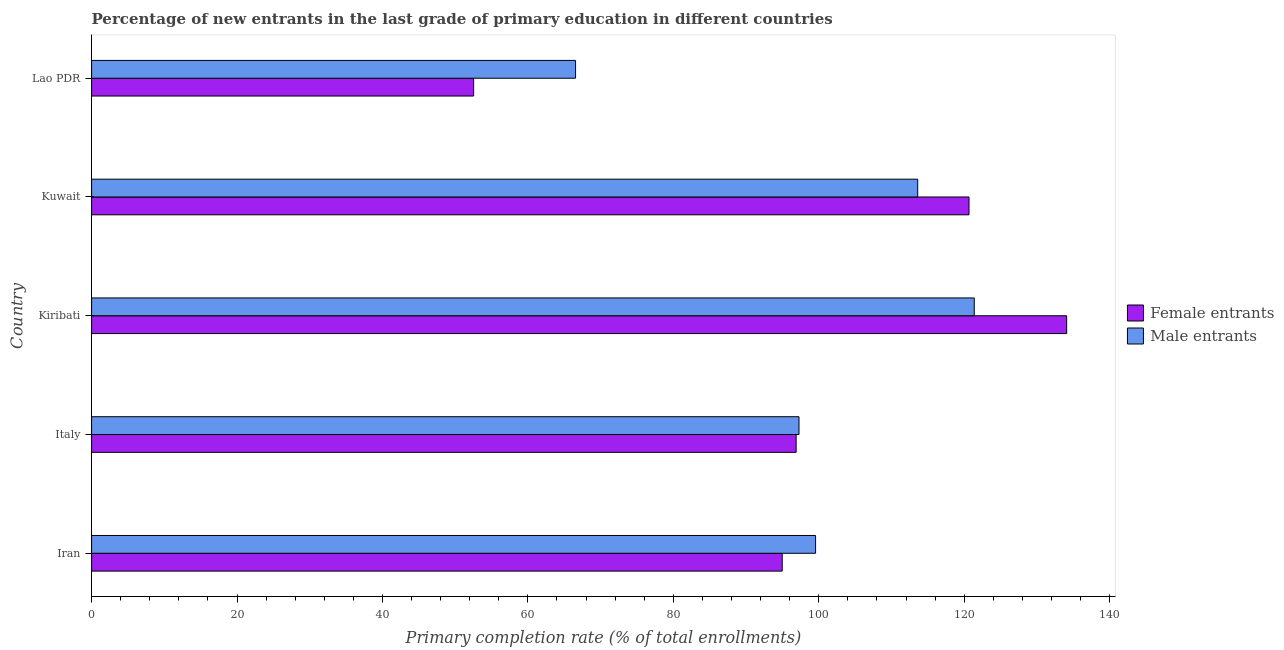How many different coloured bars are there?
Your answer should be very brief. 2. Are the number of bars per tick equal to the number of legend labels?
Provide a succinct answer. Yes. How many bars are there on the 5th tick from the top?
Offer a very short reply. 2. How many bars are there on the 3rd tick from the bottom?
Your answer should be compact. 2. What is the label of the 2nd group of bars from the top?
Ensure brevity in your answer.  Kuwait. What is the primary completion rate of female entrants in Kiribati?
Keep it short and to the point. 134.09. Across all countries, what is the maximum primary completion rate of female entrants?
Your answer should be compact. 134.09. Across all countries, what is the minimum primary completion rate of female entrants?
Keep it short and to the point. 52.54. In which country was the primary completion rate of female entrants maximum?
Provide a short and direct response. Kiribati. In which country was the primary completion rate of male entrants minimum?
Offer a very short reply. Lao PDR. What is the total primary completion rate of male entrants in the graph?
Your answer should be compact. 498.39. What is the difference between the primary completion rate of female entrants in Iran and that in Kuwait?
Make the answer very short. -25.69. What is the difference between the primary completion rate of female entrants in Iran and the primary completion rate of male entrants in Lao PDR?
Give a very brief answer. 28.42. What is the average primary completion rate of male entrants per country?
Make the answer very short. 99.68. What is the difference between the primary completion rate of male entrants and primary completion rate of female entrants in Iran?
Give a very brief answer. 4.59. In how many countries, is the primary completion rate of female entrants greater than 36 %?
Offer a very short reply. 5. What is the ratio of the primary completion rate of female entrants in Iran to that in Lao PDR?
Keep it short and to the point. 1.81. What is the difference between the highest and the second highest primary completion rate of male entrants?
Keep it short and to the point. 7.78. What is the difference between the highest and the lowest primary completion rate of male entrants?
Keep it short and to the point. 54.83. Is the sum of the primary completion rate of male entrants in Italy and Kiribati greater than the maximum primary completion rate of female entrants across all countries?
Provide a short and direct response. Yes. What does the 1st bar from the top in Iran represents?
Your answer should be compact. Male entrants. What does the 1st bar from the bottom in Iran represents?
Make the answer very short. Female entrants. How many bars are there?
Give a very brief answer. 10. Are all the bars in the graph horizontal?
Your response must be concise. Yes. How many countries are there in the graph?
Ensure brevity in your answer.  5. Does the graph contain grids?
Ensure brevity in your answer.  No. How many legend labels are there?
Make the answer very short. 2. What is the title of the graph?
Offer a terse response. Percentage of new entrants in the last grade of primary education in different countries. What is the label or title of the X-axis?
Your answer should be compact. Primary completion rate (% of total enrollments). What is the Primary completion rate (% of total enrollments) in Female entrants in Iran?
Your response must be concise. 94.97. What is the Primary completion rate (% of total enrollments) in Male entrants in Iran?
Ensure brevity in your answer.  99.56. What is the Primary completion rate (% of total enrollments) in Female entrants in Italy?
Offer a very short reply. 96.89. What is the Primary completion rate (% of total enrollments) of Male entrants in Italy?
Offer a terse response. 97.28. What is the Primary completion rate (% of total enrollments) of Female entrants in Kiribati?
Provide a succinct answer. 134.09. What is the Primary completion rate (% of total enrollments) in Male entrants in Kiribati?
Ensure brevity in your answer.  121.38. What is the Primary completion rate (% of total enrollments) in Female entrants in Kuwait?
Provide a short and direct response. 120.66. What is the Primary completion rate (% of total enrollments) in Male entrants in Kuwait?
Ensure brevity in your answer.  113.61. What is the Primary completion rate (% of total enrollments) of Female entrants in Lao PDR?
Ensure brevity in your answer.  52.54. What is the Primary completion rate (% of total enrollments) in Male entrants in Lao PDR?
Ensure brevity in your answer.  66.55. Across all countries, what is the maximum Primary completion rate (% of total enrollments) in Female entrants?
Provide a succinct answer. 134.09. Across all countries, what is the maximum Primary completion rate (% of total enrollments) of Male entrants?
Your answer should be very brief. 121.38. Across all countries, what is the minimum Primary completion rate (% of total enrollments) of Female entrants?
Offer a terse response. 52.54. Across all countries, what is the minimum Primary completion rate (% of total enrollments) in Male entrants?
Keep it short and to the point. 66.55. What is the total Primary completion rate (% of total enrollments) in Female entrants in the graph?
Provide a short and direct response. 499.15. What is the total Primary completion rate (% of total enrollments) of Male entrants in the graph?
Your response must be concise. 498.39. What is the difference between the Primary completion rate (% of total enrollments) of Female entrants in Iran and that in Italy?
Offer a terse response. -1.92. What is the difference between the Primary completion rate (% of total enrollments) of Male entrants in Iran and that in Italy?
Offer a terse response. 2.28. What is the difference between the Primary completion rate (% of total enrollments) in Female entrants in Iran and that in Kiribati?
Your answer should be compact. -39.12. What is the difference between the Primary completion rate (% of total enrollments) of Male entrants in Iran and that in Kiribati?
Your answer should be compact. -21.82. What is the difference between the Primary completion rate (% of total enrollments) in Female entrants in Iran and that in Kuwait?
Offer a very short reply. -25.69. What is the difference between the Primary completion rate (% of total enrollments) of Male entrants in Iran and that in Kuwait?
Your response must be concise. -14.04. What is the difference between the Primary completion rate (% of total enrollments) of Female entrants in Iran and that in Lao PDR?
Make the answer very short. 42.44. What is the difference between the Primary completion rate (% of total enrollments) in Male entrants in Iran and that in Lao PDR?
Provide a short and direct response. 33.01. What is the difference between the Primary completion rate (% of total enrollments) in Female entrants in Italy and that in Kiribati?
Make the answer very short. -37.21. What is the difference between the Primary completion rate (% of total enrollments) in Male entrants in Italy and that in Kiribati?
Offer a terse response. -24.1. What is the difference between the Primary completion rate (% of total enrollments) of Female entrants in Italy and that in Kuwait?
Offer a very short reply. -23.77. What is the difference between the Primary completion rate (% of total enrollments) in Male entrants in Italy and that in Kuwait?
Your answer should be very brief. -16.32. What is the difference between the Primary completion rate (% of total enrollments) in Female entrants in Italy and that in Lao PDR?
Provide a short and direct response. 44.35. What is the difference between the Primary completion rate (% of total enrollments) in Male entrants in Italy and that in Lao PDR?
Make the answer very short. 30.73. What is the difference between the Primary completion rate (% of total enrollments) in Female entrants in Kiribati and that in Kuwait?
Offer a very short reply. 13.43. What is the difference between the Primary completion rate (% of total enrollments) of Male entrants in Kiribati and that in Kuwait?
Make the answer very short. 7.78. What is the difference between the Primary completion rate (% of total enrollments) of Female entrants in Kiribati and that in Lao PDR?
Keep it short and to the point. 81.56. What is the difference between the Primary completion rate (% of total enrollments) in Male entrants in Kiribati and that in Lao PDR?
Keep it short and to the point. 54.83. What is the difference between the Primary completion rate (% of total enrollments) of Female entrants in Kuwait and that in Lao PDR?
Provide a succinct answer. 68.12. What is the difference between the Primary completion rate (% of total enrollments) in Male entrants in Kuwait and that in Lao PDR?
Provide a short and direct response. 47.05. What is the difference between the Primary completion rate (% of total enrollments) of Female entrants in Iran and the Primary completion rate (% of total enrollments) of Male entrants in Italy?
Your response must be concise. -2.31. What is the difference between the Primary completion rate (% of total enrollments) of Female entrants in Iran and the Primary completion rate (% of total enrollments) of Male entrants in Kiribati?
Keep it short and to the point. -26.41. What is the difference between the Primary completion rate (% of total enrollments) in Female entrants in Iran and the Primary completion rate (% of total enrollments) in Male entrants in Kuwait?
Your answer should be very brief. -18.63. What is the difference between the Primary completion rate (% of total enrollments) in Female entrants in Iran and the Primary completion rate (% of total enrollments) in Male entrants in Lao PDR?
Provide a short and direct response. 28.42. What is the difference between the Primary completion rate (% of total enrollments) in Female entrants in Italy and the Primary completion rate (% of total enrollments) in Male entrants in Kiribati?
Give a very brief answer. -24.5. What is the difference between the Primary completion rate (% of total enrollments) in Female entrants in Italy and the Primary completion rate (% of total enrollments) in Male entrants in Kuwait?
Your answer should be compact. -16.72. What is the difference between the Primary completion rate (% of total enrollments) of Female entrants in Italy and the Primary completion rate (% of total enrollments) of Male entrants in Lao PDR?
Give a very brief answer. 30.33. What is the difference between the Primary completion rate (% of total enrollments) in Female entrants in Kiribati and the Primary completion rate (% of total enrollments) in Male entrants in Kuwait?
Keep it short and to the point. 20.49. What is the difference between the Primary completion rate (% of total enrollments) in Female entrants in Kiribati and the Primary completion rate (% of total enrollments) in Male entrants in Lao PDR?
Provide a short and direct response. 67.54. What is the difference between the Primary completion rate (% of total enrollments) of Female entrants in Kuwait and the Primary completion rate (% of total enrollments) of Male entrants in Lao PDR?
Ensure brevity in your answer.  54.11. What is the average Primary completion rate (% of total enrollments) in Female entrants per country?
Make the answer very short. 99.83. What is the average Primary completion rate (% of total enrollments) in Male entrants per country?
Your response must be concise. 99.68. What is the difference between the Primary completion rate (% of total enrollments) in Female entrants and Primary completion rate (% of total enrollments) in Male entrants in Iran?
Ensure brevity in your answer.  -4.59. What is the difference between the Primary completion rate (% of total enrollments) of Female entrants and Primary completion rate (% of total enrollments) of Male entrants in Italy?
Give a very brief answer. -0.39. What is the difference between the Primary completion rate (% of total enrollments) of Female entrants and Primary completion rate (% of total enrollments) of Male entrants in Kiribati?
Your answer should be very brief. 12.71. What is the difference between the Primary completion rate (% of total enrollments) of Female entrants and Primary completion rate (% of total enrollments) of Male entrants in Kuwait?
Keep it short and to the point. 7.06. What is the difference between the Primary completion rate (% of total enrollments) in Female entrants and Primary completion rate (% of total enrollments) in Male entrants in Lao PDR?
Ensure brevity in your answer.  -14.02. What is the ratio of the Primary completion rate (% of total enrollments) of Female entrants in Iran to that in Italy?
Your answer should be very brief. 0.98. What is the ratio of the Primary completion rate (% of total enrollments) of Male entrants in Iran to that in Italy?
Your response must be concise. 1.02. What is the ratio of the Primary completion rate (% of total enrollments) of Female entrants in Iran to that in Kiribati?
Give a very brief answer. 0.71. What is the ratio of the Primary completion rate (% of total enrollments) in Male entrants in Iran to that in Kiribati?
Your answer should be compact. 0.82. What is the ratio of the Primary completion rate (% of total enrollments) of Female entrants in Iran to that in Kuwait?
Keep it short and to the point. 0.79. What is the ratio of the Primary completion rate (% of total enrollments) of Male entrants in Iran to that in Kuwait?
Offer a terse response. 0.88. What is the ratio of the Primary completion rate (% of total enrollments) of Female entrants in Iran to that in Lao PDR?
Ensure brevity in your answer.  1.81. What is the ratio of the Primary completion rate (% of total enrollments) of Male entrants in Iran to that in Lao PDR?
Your answer should be compact. 1.5. What is the ratio of the Primary completion rate (% of total enrollments) in Female entrants in Italy to that in Kiribati?
Offer a very short reply. 0.72. What is the ratio of the Primary completion rate (% of total enrollments) of Male entrants in Italy to that in Kiribati?
Offer a very short reply. 0.8. What is the ratio of the Primary completion rate (% of total enrollments) of Female entrants in Italy to that in Kuwait?
Ensure brevity in your answer.  0.8. What is the ratio of the Primary completion rate (% of total enrollments) of Male entrants in Italy to that in Kuwait?
Ensure brevity in your answer.  0.86. What is the ratio of the Primary completion rate (% of total enrollments) of Female entrants in Italy to that in Lao PDR?
Offer a very short reply. 1.84. What is the ratio of the Primary completion rate (% of total enrollments) of Male entrants in Italy to that in Lao PDR?
Provide a succinct answer. 1.46. What is the ratio of the Primary completion rate (% of total enrollments) in Female entrants in Kiribati to that in Kuwait?
Give a very brief answer. 1.11. What is the ratio of the Primary completion rate (% of total enrollments) of Male entrants in Kiribati to that in Kuwait?
Make the answer very short. 1.07. What is the ratio of the Primary completion rate (% of total enrollments) of Female entrants in Kiribati to that in Lao PDR?
Provide a short and direct response. 2.55. What is the ratio of the Primary completion rate (% of total enrollments) in Male entrants in Kiribati to that in Lao PDR?
Provide a succinct answer. 1.82. What is the ratio of the Primary completion rate (% of total enrollments) in Female entrants in Kuwait to that in Lao PDR?
Your answer should be very brief. 2.3. What is the ratio of the Primary completion rate (% of total enrollments) of Male entrants in Kuwait to that in Lao PDR?
Provide a succinct answer. 1.71. What is the difference between the highest and the second highest Primary completion rate (% of total enrollments) of Female entrants?
Give a very brief answer. 13.43. What is the difference between the highest and the second highest Primary completion rate (% of total enrollments) in Male entrants?
Make the answer very short. 7.78. What is the difference between the highest and the lowest Primary completion rate (% of total enrollments) in Female entrants?
Your response must be concise. 81.56. What is the difference between the highest and the lowest Primary completion rate (% of total enrollments) of Male entrants?
Offer a terse response. 54.83. 